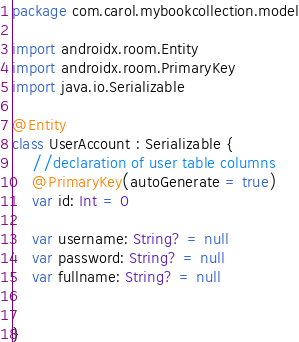<code> <loc_0><loc_0><loc_500><loc_500><_Kotlin_>package com.carol.mybookcollection.model

import androidx.room.Entity
import androidx.room.PrimaryKey
import java.io.Serializable

@Entity
class UserAccount : Serializable {
    //declaration of user table columns
    @PrimaryKey(autoGenerate = true)
    var id: Int = 0

    var username: String? = null
    var password: String? = null
    var fullname: String? = null


}


</code> 